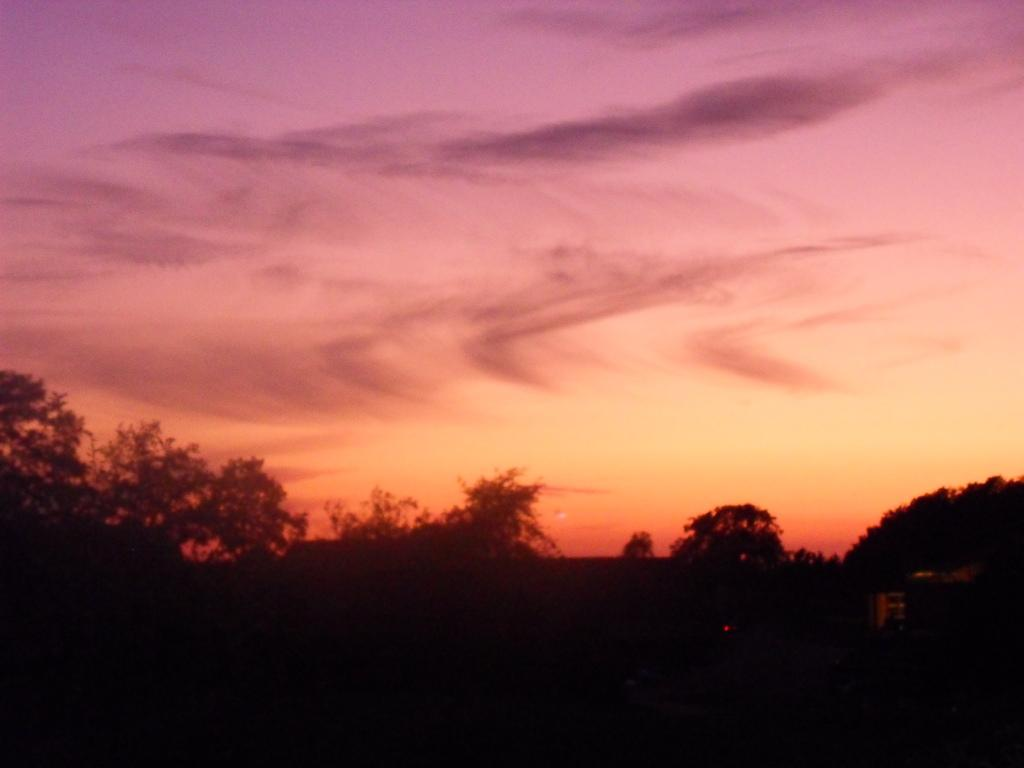What type of vegetation can be seen in the image? There are plants and trees in the image. What part of the natural environment is visible in the image? The sky is visible in the image. What can be seen in the sky? Clouds are present in the sky. Can you tell me how many times the plants have smiled in the image? Plants do not have the ability to smile, so this question cannot be answered. 